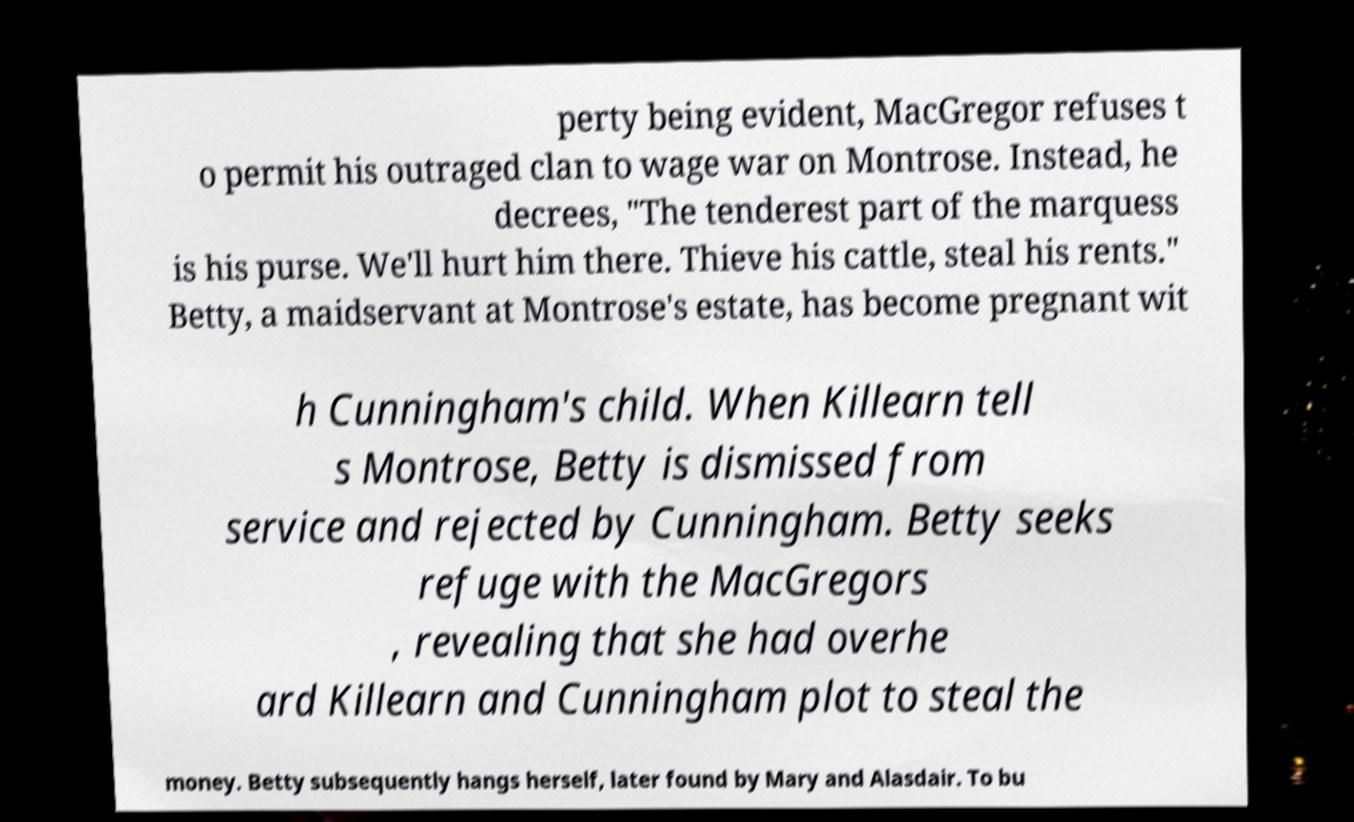For documentation purposes, I need the text within this image transcribed. Could you provide that? perty being evident, MacGregor refuses t o permit his outraged clan to wage war on Montrose. Instead, he decrees, "The tenderest part of the marquess is his purse. We'll hurt him there. Thieve his cattle, steal his rents." Betty, a maidservant at Montrose's estate, has become pregnant wit h Cunningham's child. When Killearn tell s Montrose, Betty is dismissed from service and rejected by Cunningham. Betty seeks refuge with the MacGregors , revealing that she had overhe ard Killearn and Cunningham plot to steal the money. Betty subsequently hangs herself, later found by Mary and Alasdair. To bu 